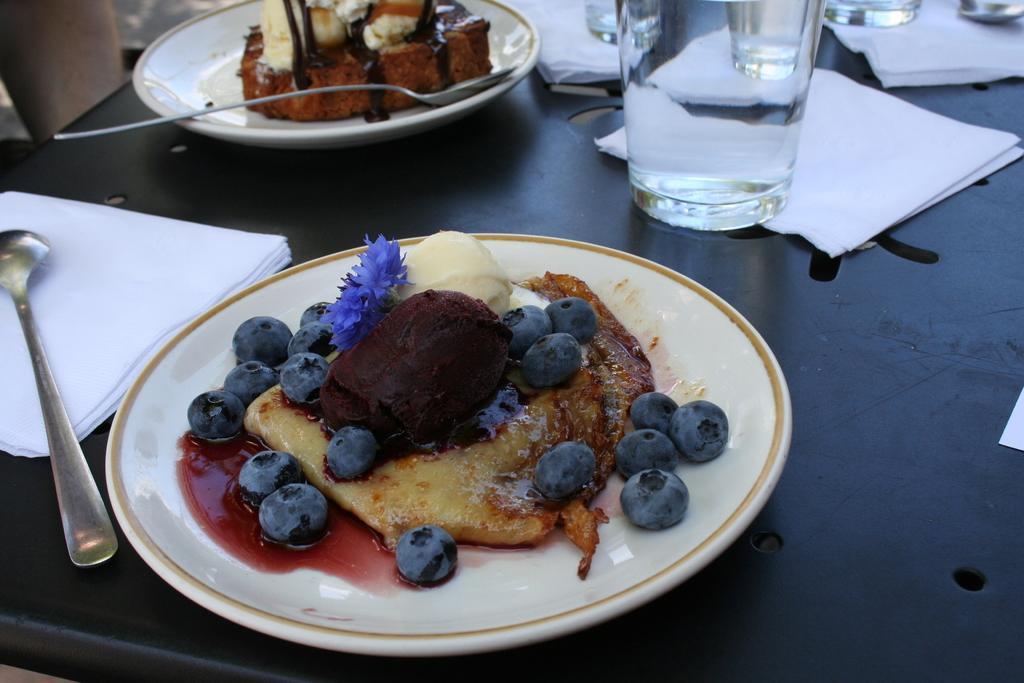Could you give a brief overview of what you see in this image? In this image we can see food items on the plates. There are few tissues, a spoon and glasses on a table. 